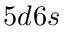<formula> <loc_0><loc_0><loc_500><loc_500>5 d 6 s</formula> 